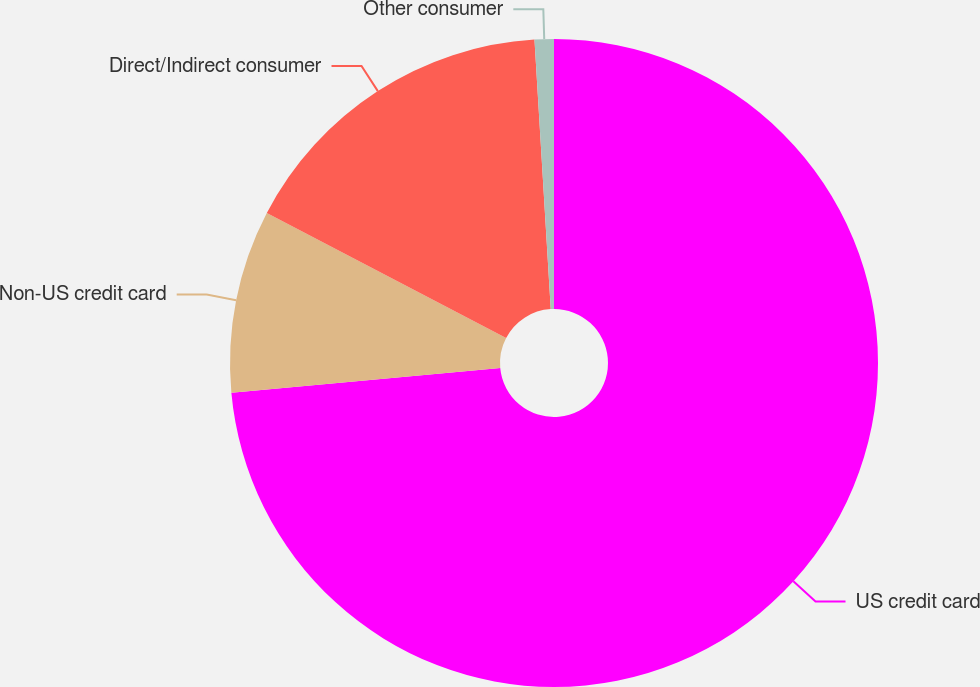<chart> <loc_0><loc_0><loc_500><loc_500><pie_chart><fcel>US credit card<fcel>Non-US credit card<fcel>Direct/Indirect consumer<fcel>Other consumer<nl><fcel>73.54%<fcel>9.12%<fcel>16.38%<fcel>0.96%<nl></chart> 